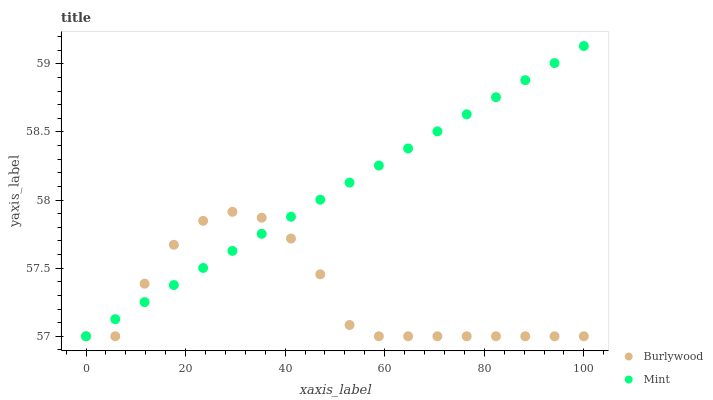Does Burlywood have the minimum area under the curve?
Answer yes or no. Yes. Does Mint have the maximum area under the curve?
Answer yes or no. Yes. Does Mint have the minimum area under the curve?
Answer yes or no. No. Is Mint the smoothest?
Answer yes or no. Yes. Is Burlywood the roughest?
Answer yes or no. Yes. Is Mint the roughest?
Answer yes or no. No. Does Burlywood have the lowest value?
Answer yes or no. Yes. Does Mint have the highest value?
Answer yes or no. Yes. Does Mint intersect Burlywood?
Answer yes or no. Yes. Is Mint less than Burlywood?
Answer yes or no. No. Is Mint greater than Burlywood?
Answer yes or no. No. 